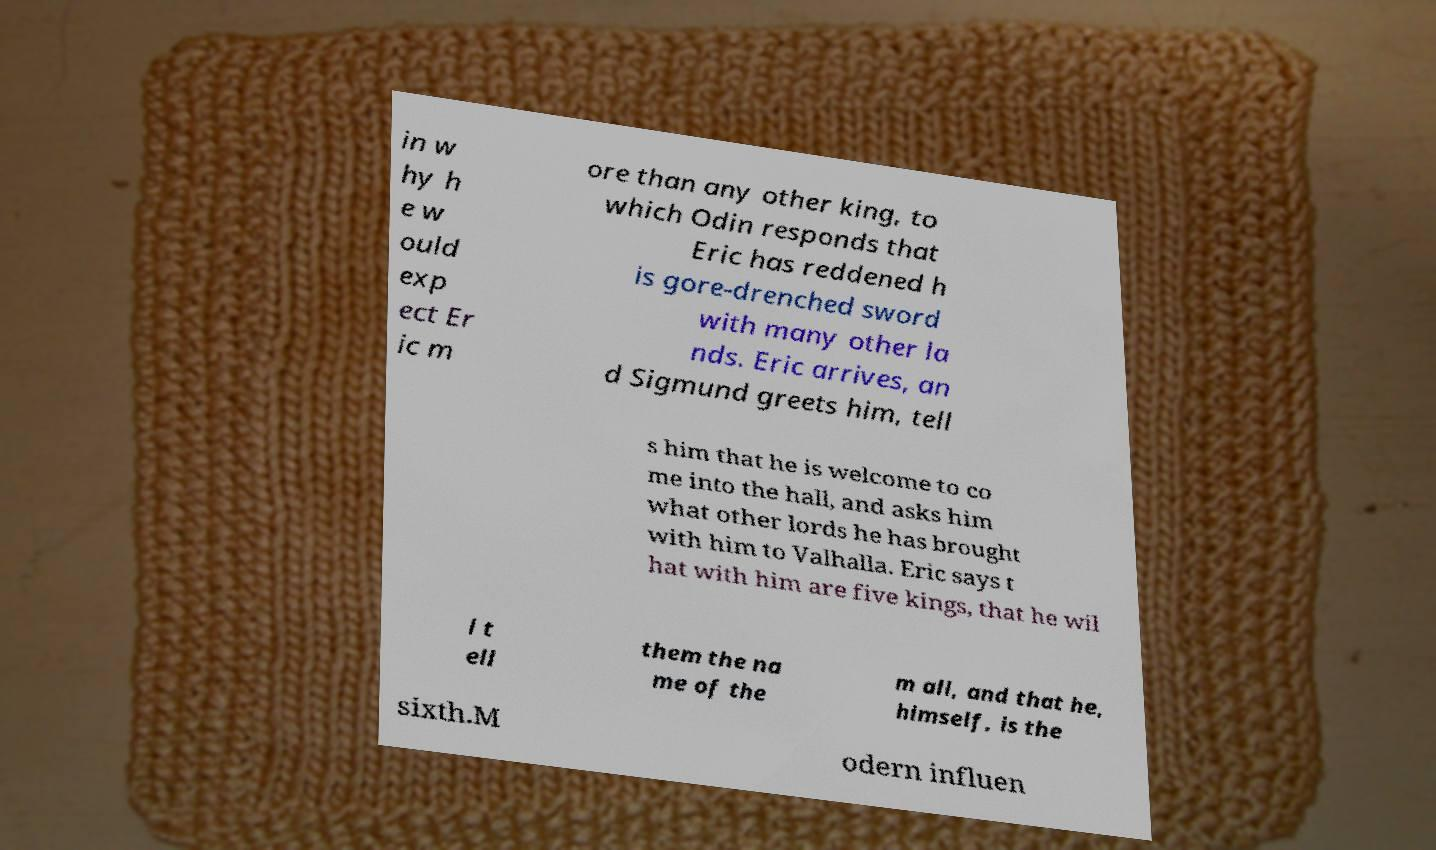Please identify and transcribe the text found in this image. in w hy h e w ould exp ect Er ic m ore than any other king, to which Odin responds that Eric has reddened h is gore-drenched sword with many other la nds. Eric arrives, an d Sigmund greets him, tell s him that he is welcome to co me into the hall, and asks him what other lords he has brought with him to Valhalla. Eric says t hat with him are five kings, that he wil l t ell them the na me of the m all, and that he, himself, is the sixth.M odern influen 